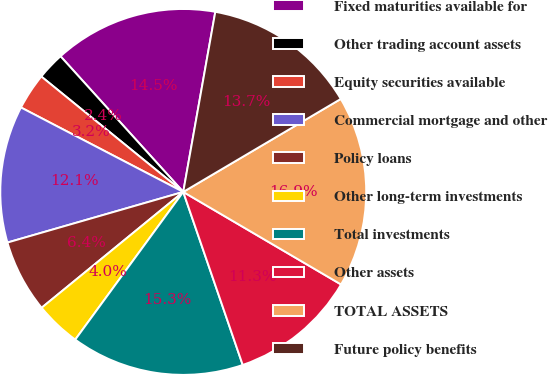<chart> <loc_0><loc_0><loc_500><loc_500><pie_chart><fcel>Fixed maturities available for<fcel>Other trading account assets<fcel>Equity securities available<fcel>Commercial mortgage and other<fcel>Policy loans<fcel>Other long-term investments<fcel>Total investments<fcel>Other assets<fcel>TOTAL ASSETS<fcel>Future policy benefits<nl><fcel>14.51%<fcel>2.43%<fcel>3.23%<fcel>12.1%<fcel>6.45%<fcel>4.04%<fcel>15.32%<fcel>11.29%<fcel>16.93%<fcel>13.71%<nl></chart> 